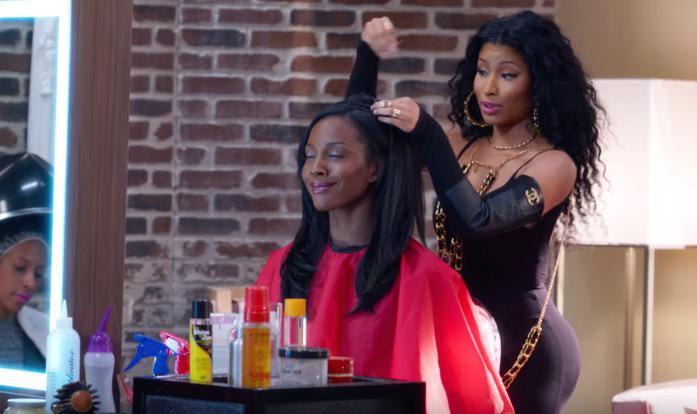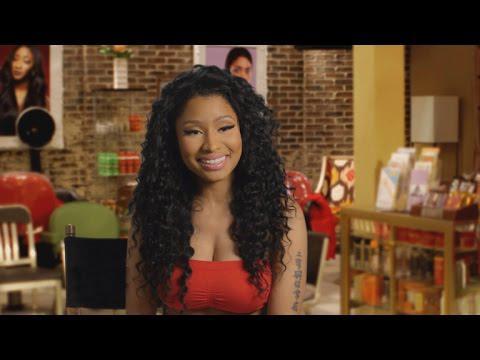The first image is the image on the left, the second image is the image on the right. Given the left and right images, does the statement "Left image shows a stylist behind a customer wearing a red smock, and right image shows a front-facing woman who is not styling hair." hold true? Answer yes or no. Yes. The first image is the image on the left, the second image is the image on the right. Evaluate the accuracy of this statement regarding the images: "A woman is doing another woman's hair in only one of the images.". Is it true? Answer yes or no. Yes. 